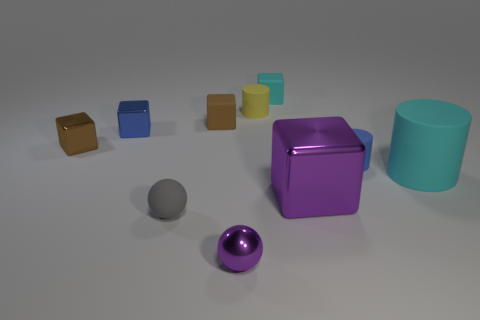Do the cyan cube and the block that is in front of the small blue matte object have the same material?
Give a very brief answer. No. What material is the small object behind the yellow matte thing?
Keep it short and to the point. Rubber. What is the size of the gray matte ball?
Keep it short and to the point. Small. There is a rubber block that is right of the small purple metal sphere; does it have the same size as the rubber cylinder that is behind the small brown rubber thing?
Offer a terse response. Yes. The purple thing that is the same shape as the tiny gray object is what size?
Ensure brevity in your answer.  Small. There is a cyan rubber cube; is its size the same as the rubber object left of the small brown matte cube?
Offer a terse response. Yes. There is a cyan object behind the big cyan cylinder; are there any brown matte things behind it?
Keep it short and to the point. No. The object that is in front of the tiny gray object has what shape?
Make the answer very short. Sphere. There is another object that is the same color as the large shiny object; what is its material?
Provide a succinct answer. Metal. The sphere that is on the left side of the purple thing that is on the left side of the small cyan block is what color?
Make the answer very short. Gray. 